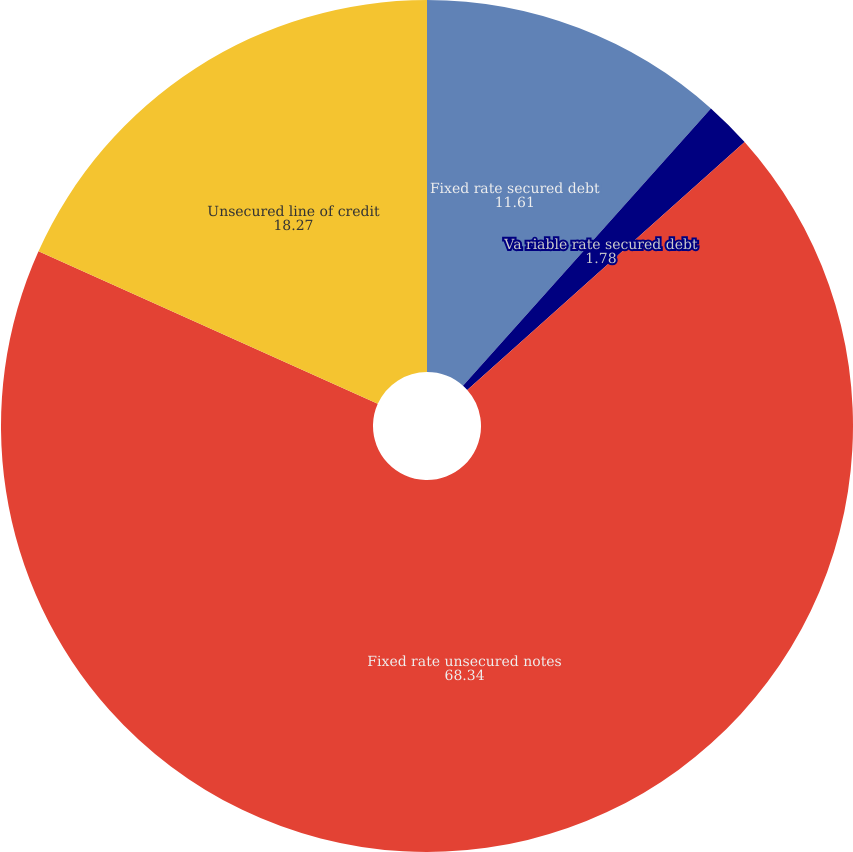Convert chart to OTSL. <chart><loc_0><loc_0><loc_500><loc_500><pie_chart><fcel>Fixed rate secured debt<fcel>Va riable rate secured debt<fcel>Fixed rate unsecured notes<fcel>Unsecured line of credit<nl><fcel>11.61%<fcel>1.78%<fcel>68.34%<fcel>18.27%<nl></chart> 